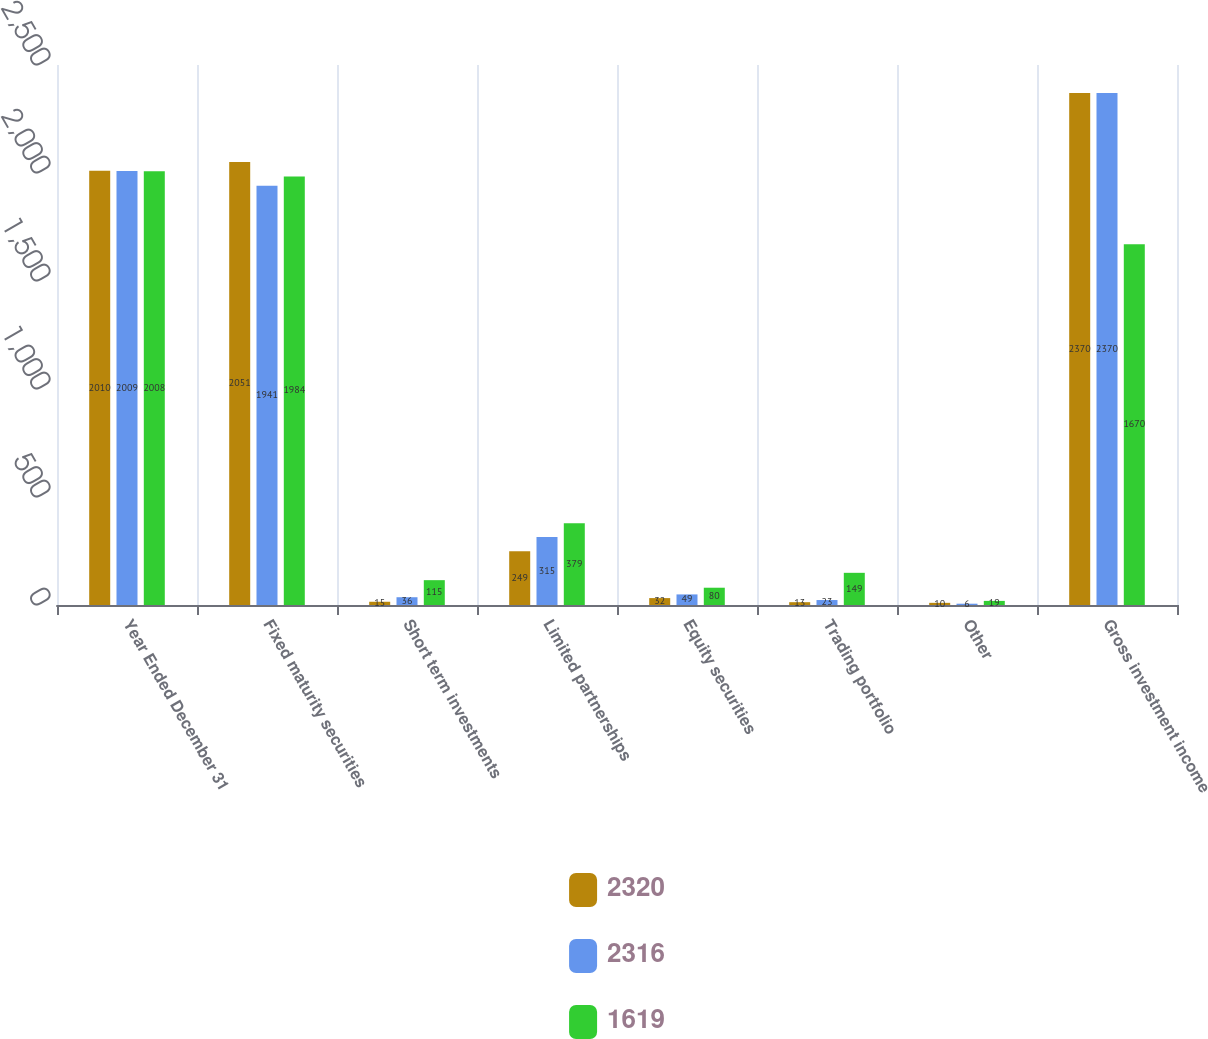<chart> <loc_0><loc_0><loc_500><loc_500><stacked_bar_chart><ecel><fcel>Year Ended December 31<fcel>Fixed maturity securities<fcel>Short term investments<fcel>Limited partnerships<fcel>Equity securities<fcel>Trading portfolio<fcel>Other<fcel>Gross investment income<nl><fcel>2320<fcel>2010<fcel>2051<fcel>15<fcel>249<fcel>32<fcel>13<fcel>10<fcel>2370<nl><fcel>2316<fcel>2009<fcel>1941<fcel>36<fcel>315<fcel>49<fcel>23<fcel>6<fcel>2370<nl><fcel>1619<fcel>2008<fcel>1984<fcel>115<fcel>379<fcel>80<fcel>149<fcel>19<fcel>1670<nl></chart> 